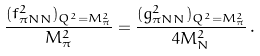Convert formula to latex. <formula><loc_0><loc_0><loc_500><loc_500>\frac { ( f _ { \pi N N } ^ { 2 } ) _ { Q ^ { 2 } = M _ { \pi } ^ { 2 } } } { M _ { \pi } ^ { 2 } } = \frac { ( g _ { \pi N N } ^ { 2 } ) _ { Q ^ { 2 } = M _ { \pi } ^ { 2 } } } { 4 M _ { N } ^ { 2 } } \, .</formula> 